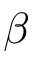<formula> <loc_0><loc_0><loc_500><loc_500>\beta</formula> 